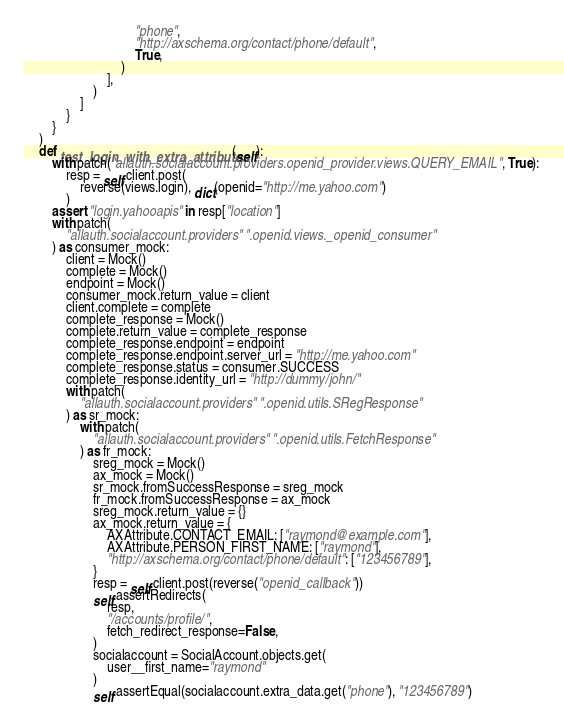Convert code to text. <code><loc_0><loc_0><loc_500><loc_500><_Python_>                                "phone",
                                "http://axschema.org/contact/phone/default",
                                True,
                            )
                        ],
                    )
                ]
            }
        }
    )
    def test_login_with_extra_attributes(self):
        with patch("allauth.socialaccount.providers.openid_provider.views.QUERY_EMAIL", True):
            resp = self.client.post(
                reverse(views.login), dict(openid="http://me.yahoo.com")
            )
        assert "login.yahooapis" in resp["location"]
        with patch(
            "allauth.socialaccount.providers" ".openid.views._openid_consumer"
        ) as consumer_mock:
            client = Mock()
            complete = Mock()
            endpoint = Mock()
            consumer_mock.return_value = client
            client.complete = complete
            complete_response = Mock()
            complete.return_value = complete_response
            complete_response.endpoint = endpoint
            complete_response.endpoint.server_url = "http://me.yahoo.com"
            complete_response.status = consumer.SUCCESS
            complete_response.identity_url = "http://dummy/john/"
            with patch(
                "allauth.socialaccount.providers" ".openid.utils.SRegResponse"
            ) as sr_mock:
                with patch(
                    "allauth.socialaccount.providers" ".openid.utils.FetchResponse"
                ) as fr_mock:
                    sreg_mock = Mock()
                    ax_mock = Mock()
                    sr_mock.fromSuccessResponse = sreg_mock
                    fr_mock.fromSuccessResponse = ax_mock
                    sreg_mock.return_value = {}
                    ax_mock.return_value = {
                        AXAttribute.CONTACT_EMAIL: ["raymond@example.com"],
                        AXAttribute.PERSON_FIRST_NAME: ["raymond"],
                        "http://axschema.org/contact/phone/default": ["123456789"],
                    }
                    resp = self.client.post(reverse("openid_callback"))
                    self.assertRedirects(
                        resp,
                        "/accounts/profile/",
                        fetch_redirect_response=False,
                    )
                    socialaccount = SocialAccount.objects.get(
                        user__first_name="raymond"
                    )
                    self.assertEqual(socialaccount.extra_data.get("phone"), "123456789")
</code> 